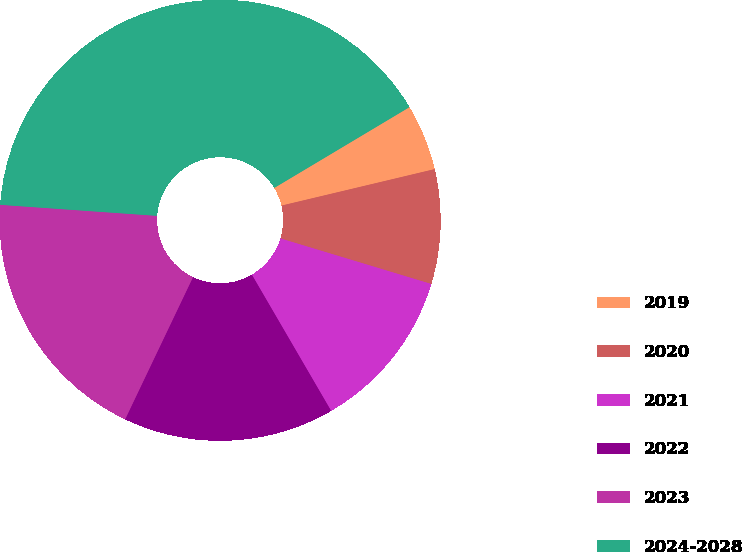<chart> <loc_0><loc_0><loc_500><loc_500><pie_chart><fcel>2019<fcel>2020<fcel>2021<fcel>2022<fcel>2023<fcel>2024-2028<nl><fcel>4.85%<fcel>8.39%<fcel>11.94%<fcel>15.48%<fcel>19.03%<fcel>40.31%<nl></chart> 